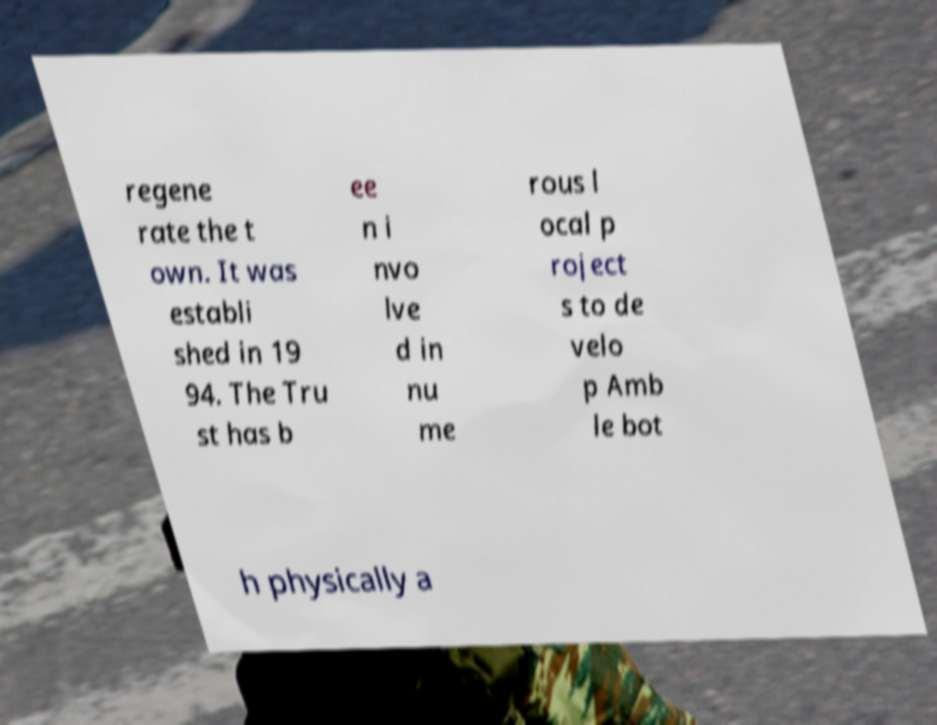I need the written content from this picture converted into text. Can you do that? regene rate the t own. It was establi shed in 19 94. The Tru st has b ee n i nvo lve d in nu me rous l ocal p roject s to de velo p Amb le bot h physically a 